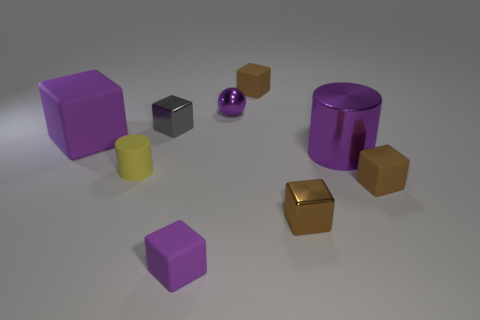Is the number of brown rubber cubes that are on the right side of the yellow matte thing greater than the number of yellow things?
Offer a terse response. Yes. There is a matte cylinder that is the same size as the gray object; what is its color?
Provide a short and direct response. Yellow. How many things are either small brown matte cubes that are left of the large purple metallic cylinder or shiny balls?
Provide a succinct answer. 2. The small matte thing that is the same color as the tiny shiny sphere is what shape?
Offer a terse response. Cube. What is the big thing on the right side of the brown rubber block that is behind the small ball made of?
Offer a very short reply. Metal. Are there any small red things made of the same material as the ball?
Offer a very short reply. No. Is there a small purple cube in front of the brown matte object in front of the yellow rubber cylinder?
Keep it short and to the point. Yes. What is the material of the large purple object right of the yellow matte cylinder?
Your answer should be compact. Metal. Is the shape of the small gray thing the same as the tiny brown shiny object?
Your answer should be compact. Yes. The small matte block that is in front of the tiny matte thing that is to the right of the rubber thing that is behind the small gray object is what color?
Your answer should be compact. Purple. 